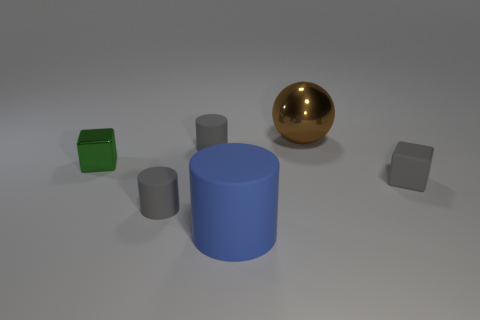What is the size of the gray cube that is the same material as the blue thing?
Offer a terse response. Small. Are there any tiny cylinders that have the same color as the small matte block?
Give a very brief answer. Yes. Is the size of the gray matte object that is to the right of the brown metal sphere the same as the shiny ball?
Make the answer very short. No. Are there an equal number of tiny gray rubber objects behind the small green cube and gray cubes?
Provide a succinct answer. Yes. How many things are either rubber things that are on the right side of the blue rubber thing or rubber cylinders?
Keep it short and to the point. 4. The object that is in front of the matte block and behind the large rubber thing has what shape?
Provide a succinct answer. Cylinder. How many things are matte things that are on the right side of the big blue matte object or matte objects that are behind the big cylinder?
Offer a terse response. 3. How many other things are the same size as the ball?
Provide a short and direct response. 1. There is a small matte thing behind the tiny green metallic cube; is it the same color as the rubber cube?
Offer a very short reply. Yes. How big is the thing that is on the right side of the blue cylinder and behind the metallic cube?
Your response must be concise. Large. 